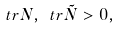Convert formula to latex. <formula><loc_0><loc_0><loc_500><loc_500>\ t r N , \ t r \tilde { N } > 0 ,</formula> 